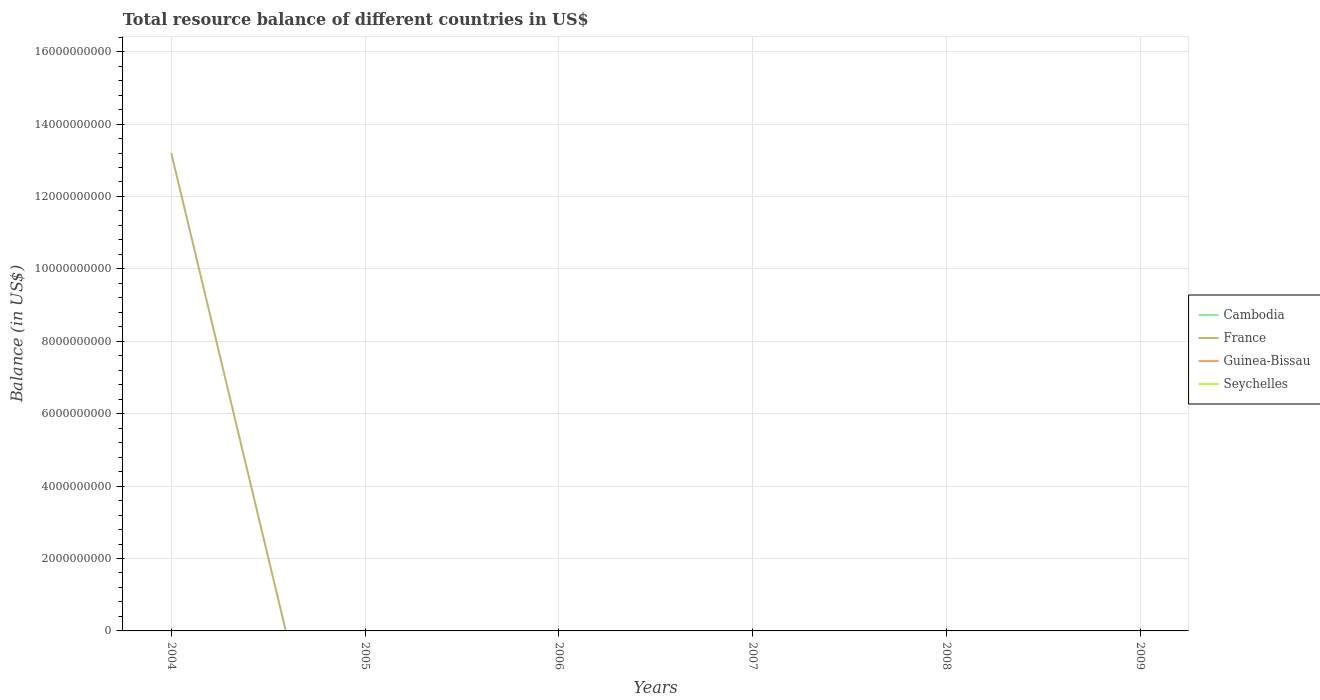Does the line corresponding to Seychelles intersect with the line corresponding to Cambodia?
Ensure brevity in your answer.  No. Is the number of lines equal to the number of legend labels?
Make the answer very short. No. What is the difference between the highest and the lowest total resource balance in Seychelles?
Keep it short and to the point. 0. Is the total resource balance in Cambodia strictly greater than the total resource balance in Guinea-Bissau over the years?
Provide a short and direct response. Yes. What is the difference between two consecutive major ticks on the Y-axis?
Provide a succinct answer. 2.00e+09. Does the graph contain any zero values?
Offer a very short reply. Yes. Does the graph contain grids?
Offer a terse response. Yes. Where does the legend appear in the graph?
Offer a terse response. Center right. How many legend labels are there?
Offer a terse response. 4. What is the title of the graph?
Ensure brevity in your answer.  Total resource balance of different countries in US$. What is the label or title of the Y-axis?
Keep it short and to the point. Balance (in US$). What is the Balance (in US$) of France in 2004?
Your answer should be compact. 1.32e+1. What is the Balance (in US$) of Seychelles in 2004?
Provide a succinct answer. 0. What is the Balance (in US$) of Cambodia in 2005?
Give a very brief answer. 0. What is the Balance (in US$) in Seychelles in 2005?
Give a very brief answer. 0. What is the Balance (in US$) of Cambodia in 2006?
Provide a succinct answer. 0. What is the Balance (in US$) in France in 2006?
Keep it short and to the point. 0. What is the Balance (in US$) of Guinea-Bissau in 2006?
Your answer should be compact. 0. What is the Balance (in US$) of Seychelles in 2006?
Offer a terse response. 0. What is the Balance (in US$) in France in 2007?
Offer a terse response. 0. What is the Balance (in US$) in Guinea-Bissau in 2007?
Offer a terse response. 0. What is the Balance (in US$) of Seychelles in 2007?
Offer a terse response. 0. What is the Balance (in US$) in Seychelles in 2009?
Make the answer very short. 0. Across all years, what is the maximum Balance (in US$) of France?
Keep it short and to the point. 1.32e+1. What is the total Balance (in US$) of Cambodia in the graph?
Keep it short and to the point. 0. What is the total Balance (in US$) in France in the graph?
Offer a very short reply. 1.32e+1. What is the total Balance (in US$) in Guinea-Bissau in the graph?
Offer a very short reply. 0. What is the average Balance (in US$) in Cambodia per year?
Make the answer very short. 0. What is the average Balance (in US$) of France per year?
Offer a terse response. 2.20e+09. What is the average Balance (in US$) in Guinea-Bissau per year?
Make the answer very short. 0. What is the difference between the highest and the lowest Balance (in US$) of France?
Keep it short and to the point. 1.32e+1. 